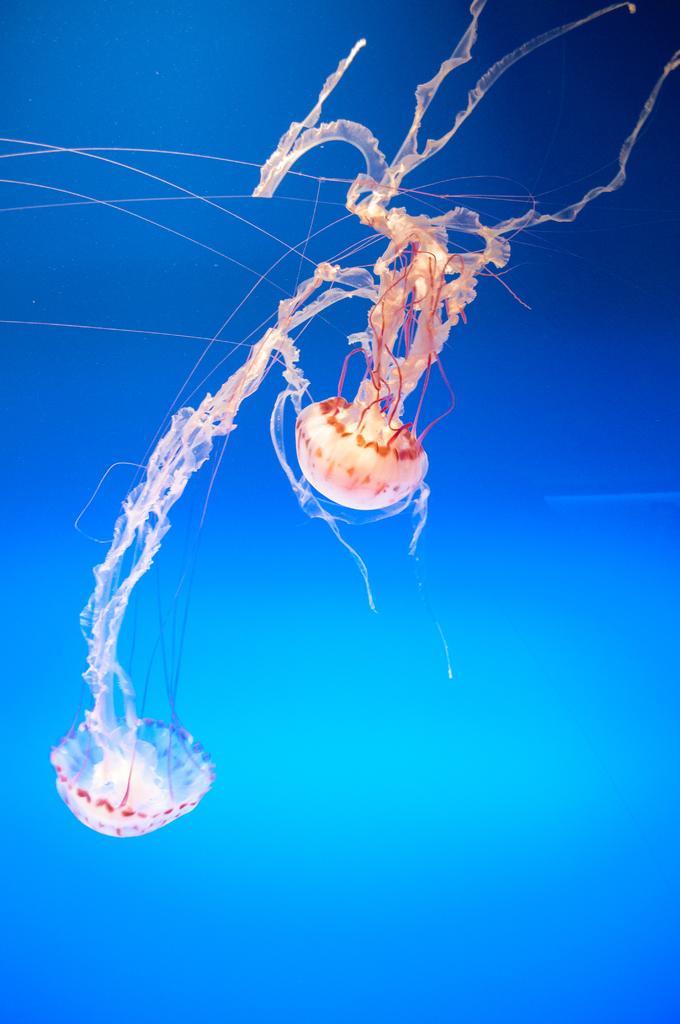Please provide a concise description of this image. Background portion of the picture is in blue color. In this picture we can see the jellyfish. 